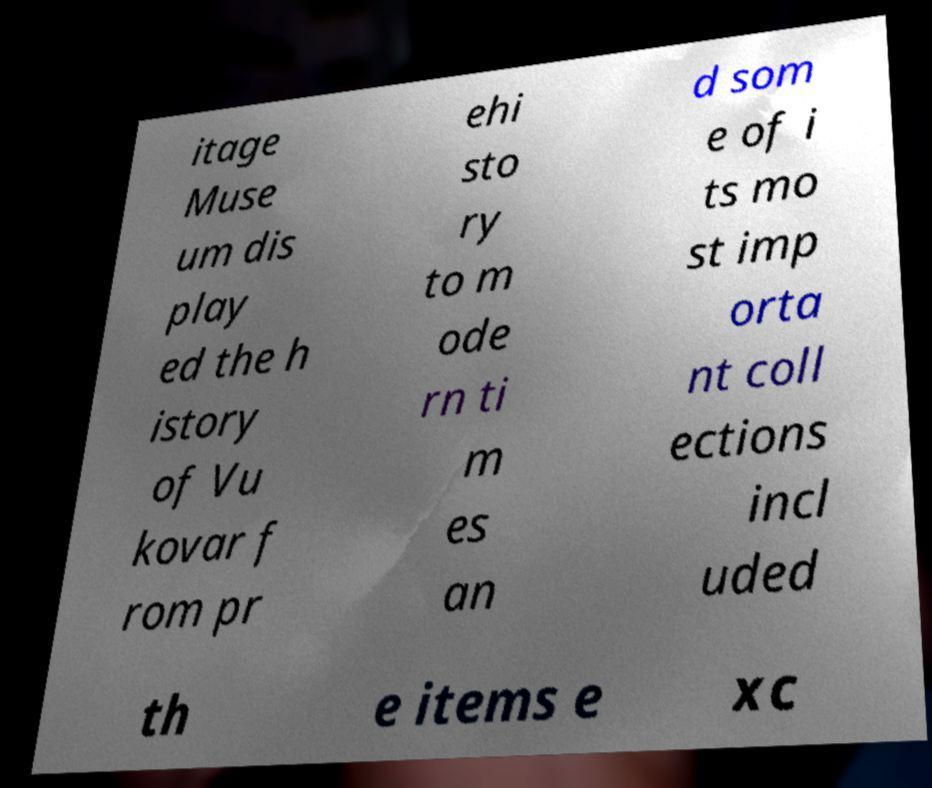I need the written content from this picture converted into text. Can you do that? itage Muse um dis play ed the h istory of Vu kovar f rom pr ehi sto ry to m ode rn ti m es an d som e of i ts mo st imp orta nt coll ections incl uded th e items e xc 